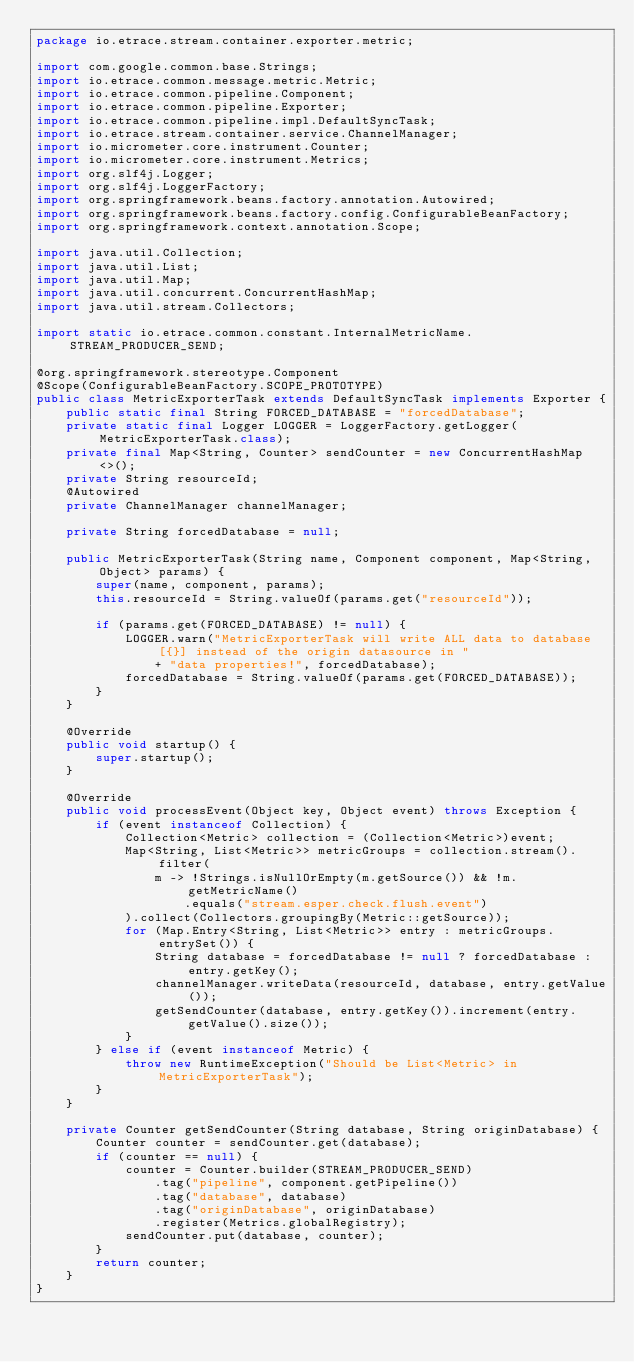<code> <loc_0><loc_0><loc_500><loc_500><_Java_>package io.etrace.stream.container.exporter.metric;

import com.google.common.base.Strings;
import io.etrace.common.message.metric.Metric;
import io.etrace.common.pipeline.Component;
import io.etrace.common.pipeline.Exporter;
import io.etrace.common.pipeline.impl.DefaultSyncTask;
import io.etrace.stream.container.service.ChannelManager;
import io.micrometer.core.instrument.Counter;
import io.micrometer.core.instrument.Metrics;
import org.slf4j.Logger;
import org.slf4j.LoggerFactory;
import org.springframework.beans.factory.annotation.Autowired;
import org.springframework.beans.factory.config.ConfigurableBeanFactory;
import org.springframework.context.annotation.Scope;

import java.util.Collection;
import java.util.List;
import java.util.Map;
import java.util.concurrent.ConcurrentHashMap;
import java.util.stream.Collectors;

import static io.etrace.common.constant.InternalMetricName.STREAM_PRODUCER_SEND;

@org.springframework.stereotype.Component
@Scope(ConfigurableBeanFactory.SCOPE_PROTOTYPE)
public class MetricExporterTask extends DefaultSyncTask implements Exporter {
    public static final String FORCED_DATABASE = "forcedDatabase";
    private static final Logger LOGGER = LoggerFactory.getLogger(MetricExporterTask.class);
    private final Map<String, Counter> sendCounter = new ConcurrentHashMap<>();
    private String resourceId;
    @Autowired
    private ChannelManager channelManager;

    private String forcedDatabase = null;

    public MetricExporterTask(String name, Component component, Map<String, Object> params) {
        super(name, component, params);
        this.resourceId = String.valueOf(params.get("resourceId"));

        if (params.get(FORCED_DATABASE) != null) {
            LOGGER.warn("MetricExporterTask will write ALL data to database [{}] instead of the origin datasource in "
                + "data properties!", forcedDatabase);
            forcedDatabase = String.valueOf(params.get(FORCED_DATABASE));
        }
    }

    @Override
    public void startup() {
        super.startup();
    }

    @Override
    public void processEvent(Object key, Object event) throws Exception {
        if (event instanceof Collection) {
            Collection<Metric> collection = (Collection<Metric>)event;
            Map<String, List<Metric>> metricGroups = collection.stream().filter(
                m -> !Strings.isNullOrEmpty(m.getSource()) && !m.getMetricName()
                    .equals("stream.esper.check.flush.event")
            ).collect(Collectors.groupingBy(Metric::getSource));
            for (Map.Entry<String, List<Metric>> entry : metricGroups.entrySet()) {
                String database = forcedDatabase != null ? forcedDatabase : entry.getKey();
                channelManager.writeData(resourceId, database, entry.getValue());
                getSendCounter(database, entry.getKey()).increment(entry.getValue().size());
            }
        } else if (event instanceof Metric) {
            throw new RuntimeException("Should be List<Metric> in MetricExporterTask");
        }
    }

    private Counter getSendCounter(String database, String originDatabase) {
        Counter counter = sendCounter.get(database);
        if (counter == null) {
            counter = Counter.builder(STREAM_PRODUCER_SEND)
                .tag("pipeline", component.getPipeline())
                .tag("database", database)
                .tag("originDatabase", originDatabase)
                .register(Metrics.globalRegistry);
            sendCounter.put(database, counter);
        }
        return counter;
    }
}
</code> 